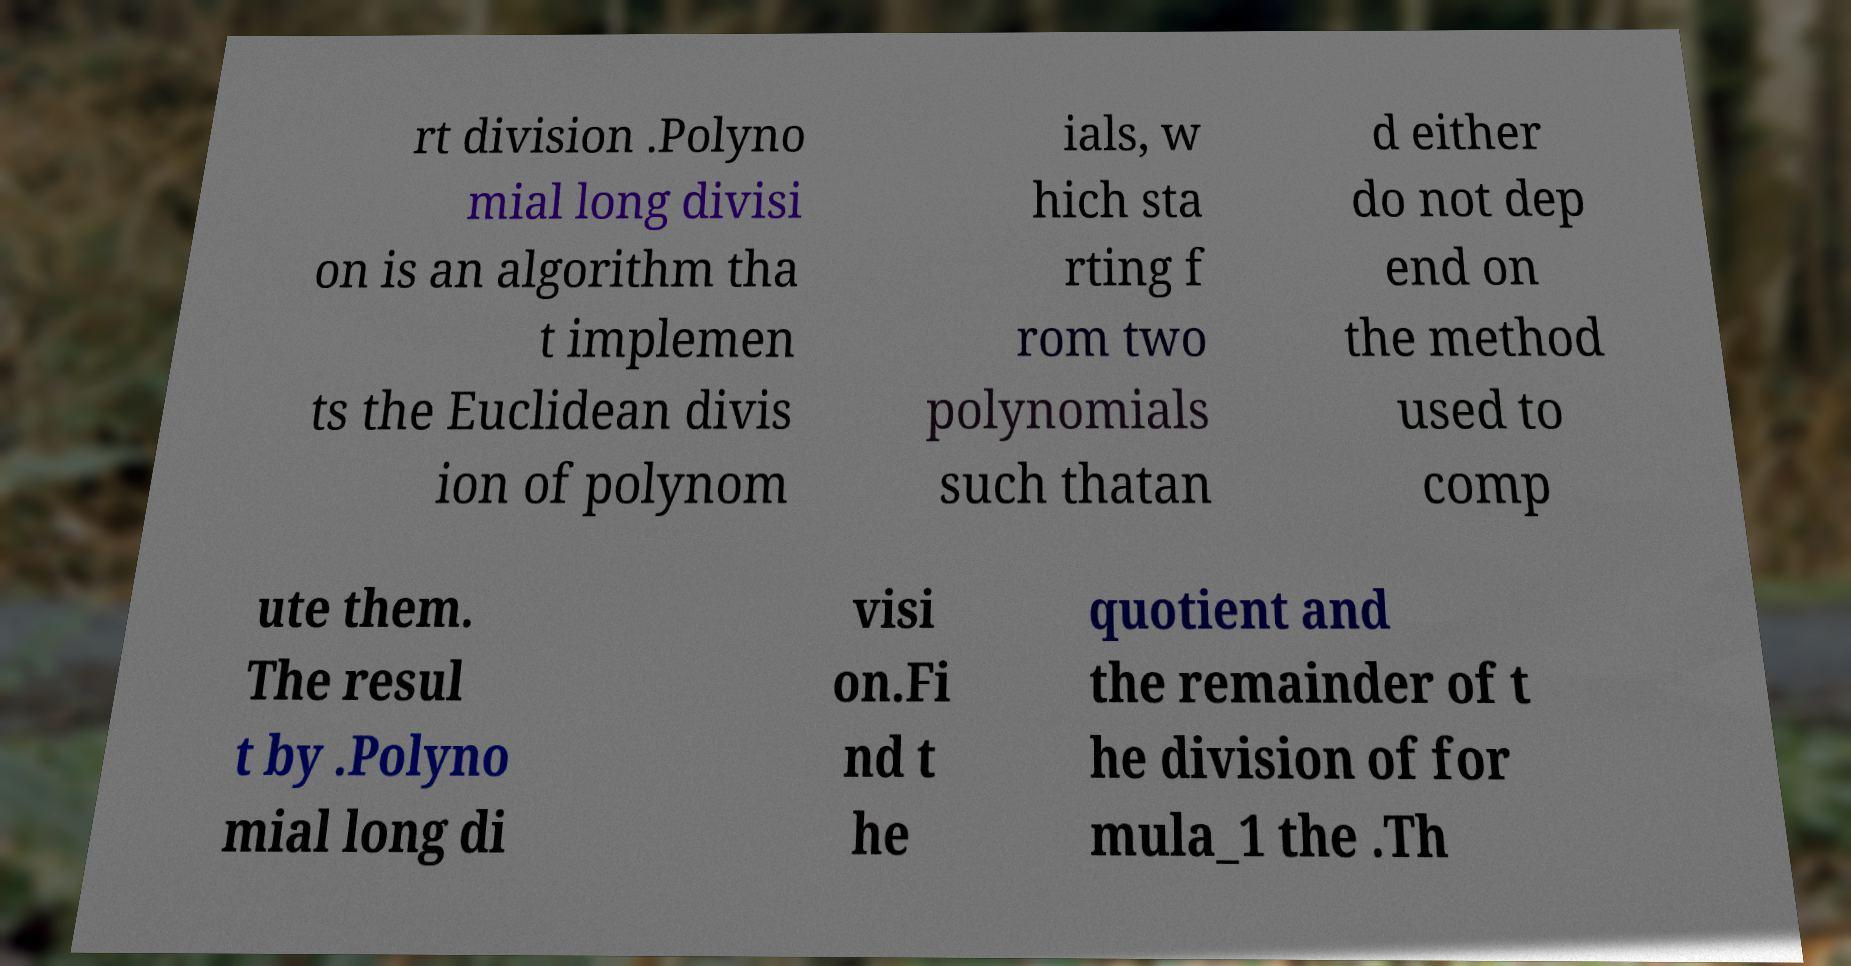For documentation purposes, I need the text within this image transcribed. Could you provide that? rt division .Polyno mial long divisi on is an algorithm tha t implemen ts the Euclidean divis ion of polynom ials, w hich sta rting f rom two polynomials such thatan d either do not dep end on the method used to comp ute them. The resul t by .Polyno mial long di visi on.Fi nd t he quotient and the remainder of t he division of for mula_1 the .Th 